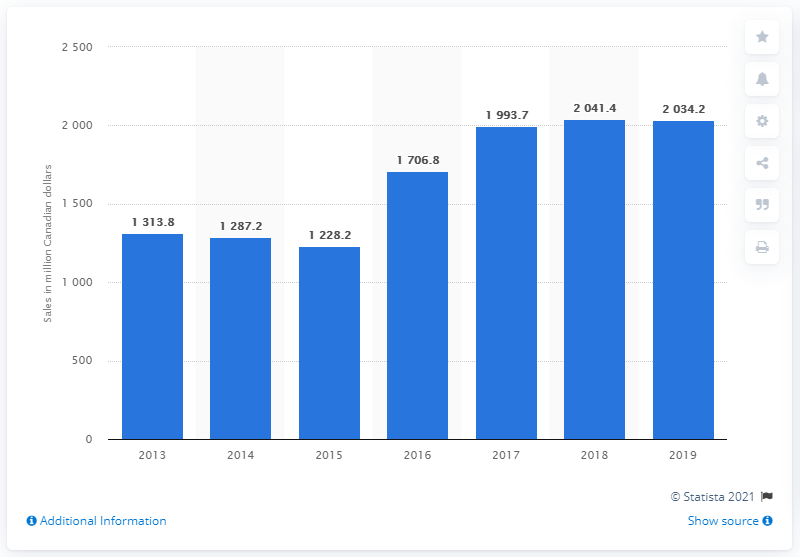Indicate a few pertinent items in this graphic. In 2019, the sales of Molson Coors Brewing Company in Canada were reported. 